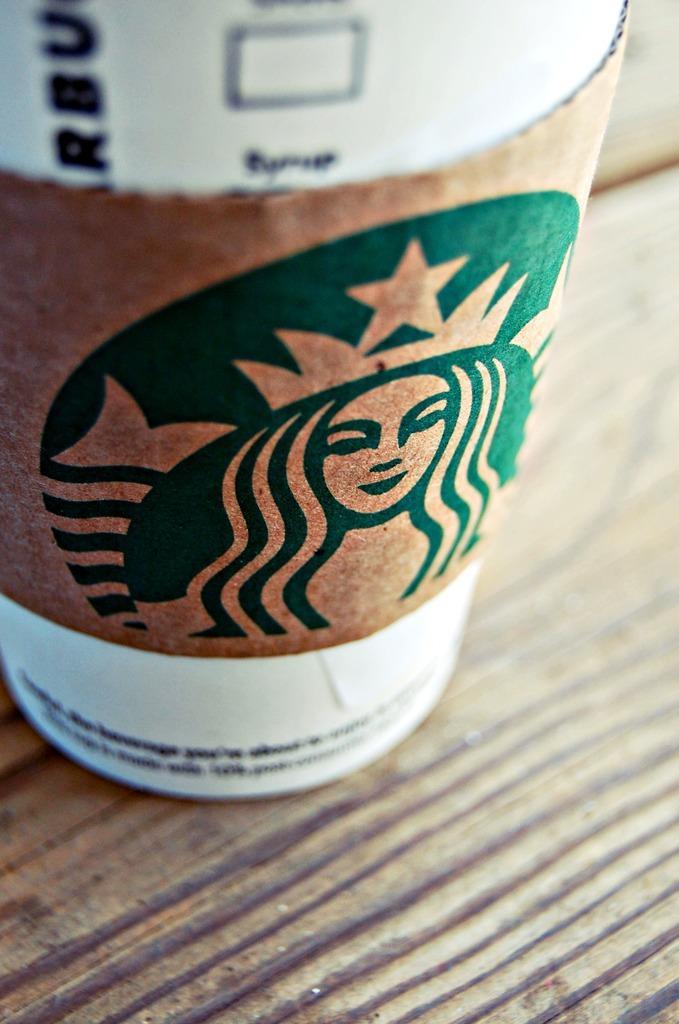In one or two sentences, can you explain what this image depicts? In this image, there is a cup which is kept on the table, on which woman´is painting is there. This image is taken inside a room. 